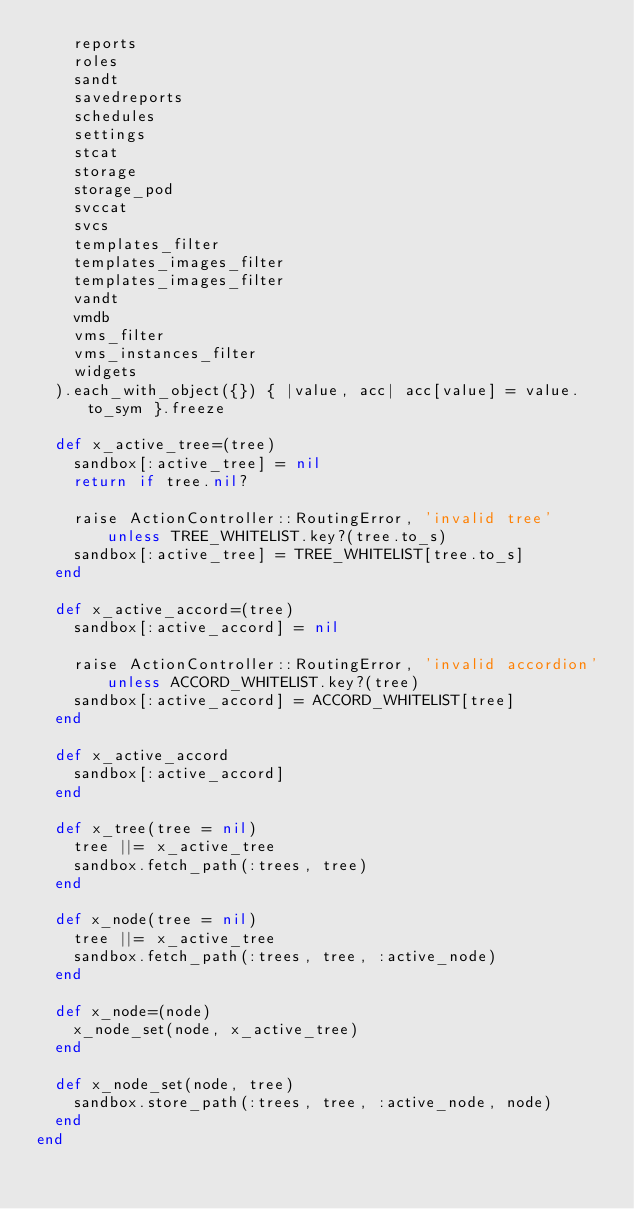Convert code to text. <code><loc_0><loc_0><loc_500><loc_500><_Ruby_>    reports
    roles
    sandt
    savedreports
    schedules
    settings
    stcat
    storage
    storage_pod
    svccat
    svcs
    templates_filter
    templates_images_filter
    templates_images_filter
    vandt
    vmdb
    vms_filter
    vms_instances_filter
    widgets
  ).each_with_object({}) { |value, acc| acc[value] = value.to_sym }.freeze

  def x_active_tree=(tree)
    sandbox[:active_tree] = nil
    return if tree.nil?

    raise ActionController::RoutingError, 'invalid tree' unless TREE_WHITELIST.key?(tree.to_s)
    sandbox[:active_tree] = TREE_WHITELIST[tree.to_s]
  end

  def x_active_accord=(tree)
    sandbox[:active_accord] = nil

    raise ActionController::RoutingError, 'invalid accordion' unless ACCORD_WHITELIST.key?(tree)
    sandbox[:active_accord] = ACCORD_WHITELIST[tree]
  end

  def x_active_accord
    sandbox[:active_accord]
  end

  def x_tree(tree = nil)
    tree ||= x_active_tree
    sandbox.fetch_path(:trees, tree)
  end

  def x_node(tree = nil)
    tree ||= x_active_tree
    sandbox.fetch_path(:trees, tree, :active_node)
  end

  def x_node=(node)
    x_node_set(node, x_active_tree)
  end

  def x_node_set(node, tree)
    sandbox.store_path(:trees, tree, :active_node, node)
  end
end
</code> 